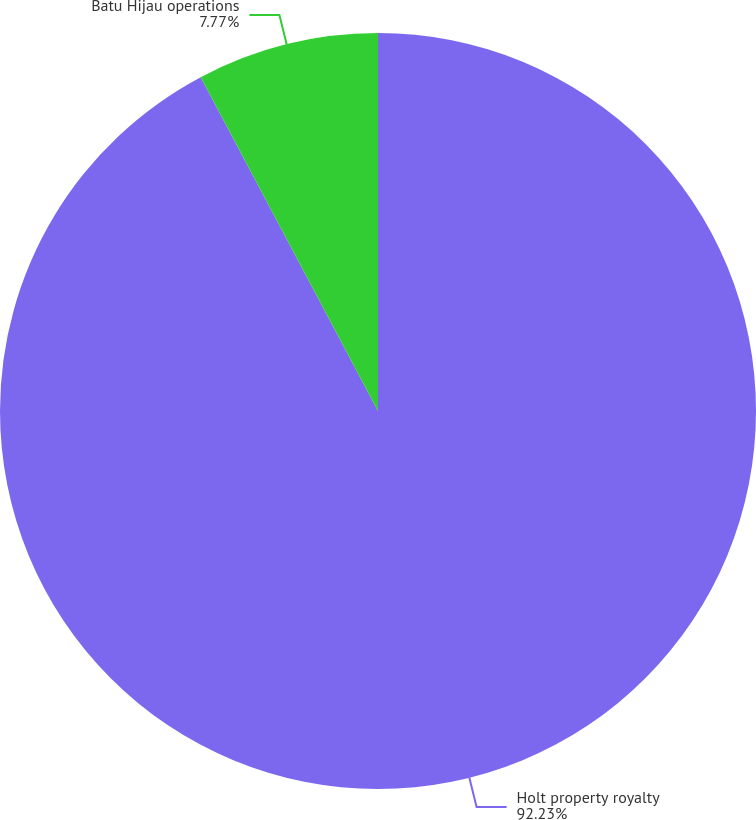Convert chart to OTSL. <chart><loc_0><loc_0><loc_500><loc_500><pie_chart><fcel>Holt property royalty<fcel>Batu Hijau operations<nl><fcel>92.23%<fcel>7.77%<nl></chart> 